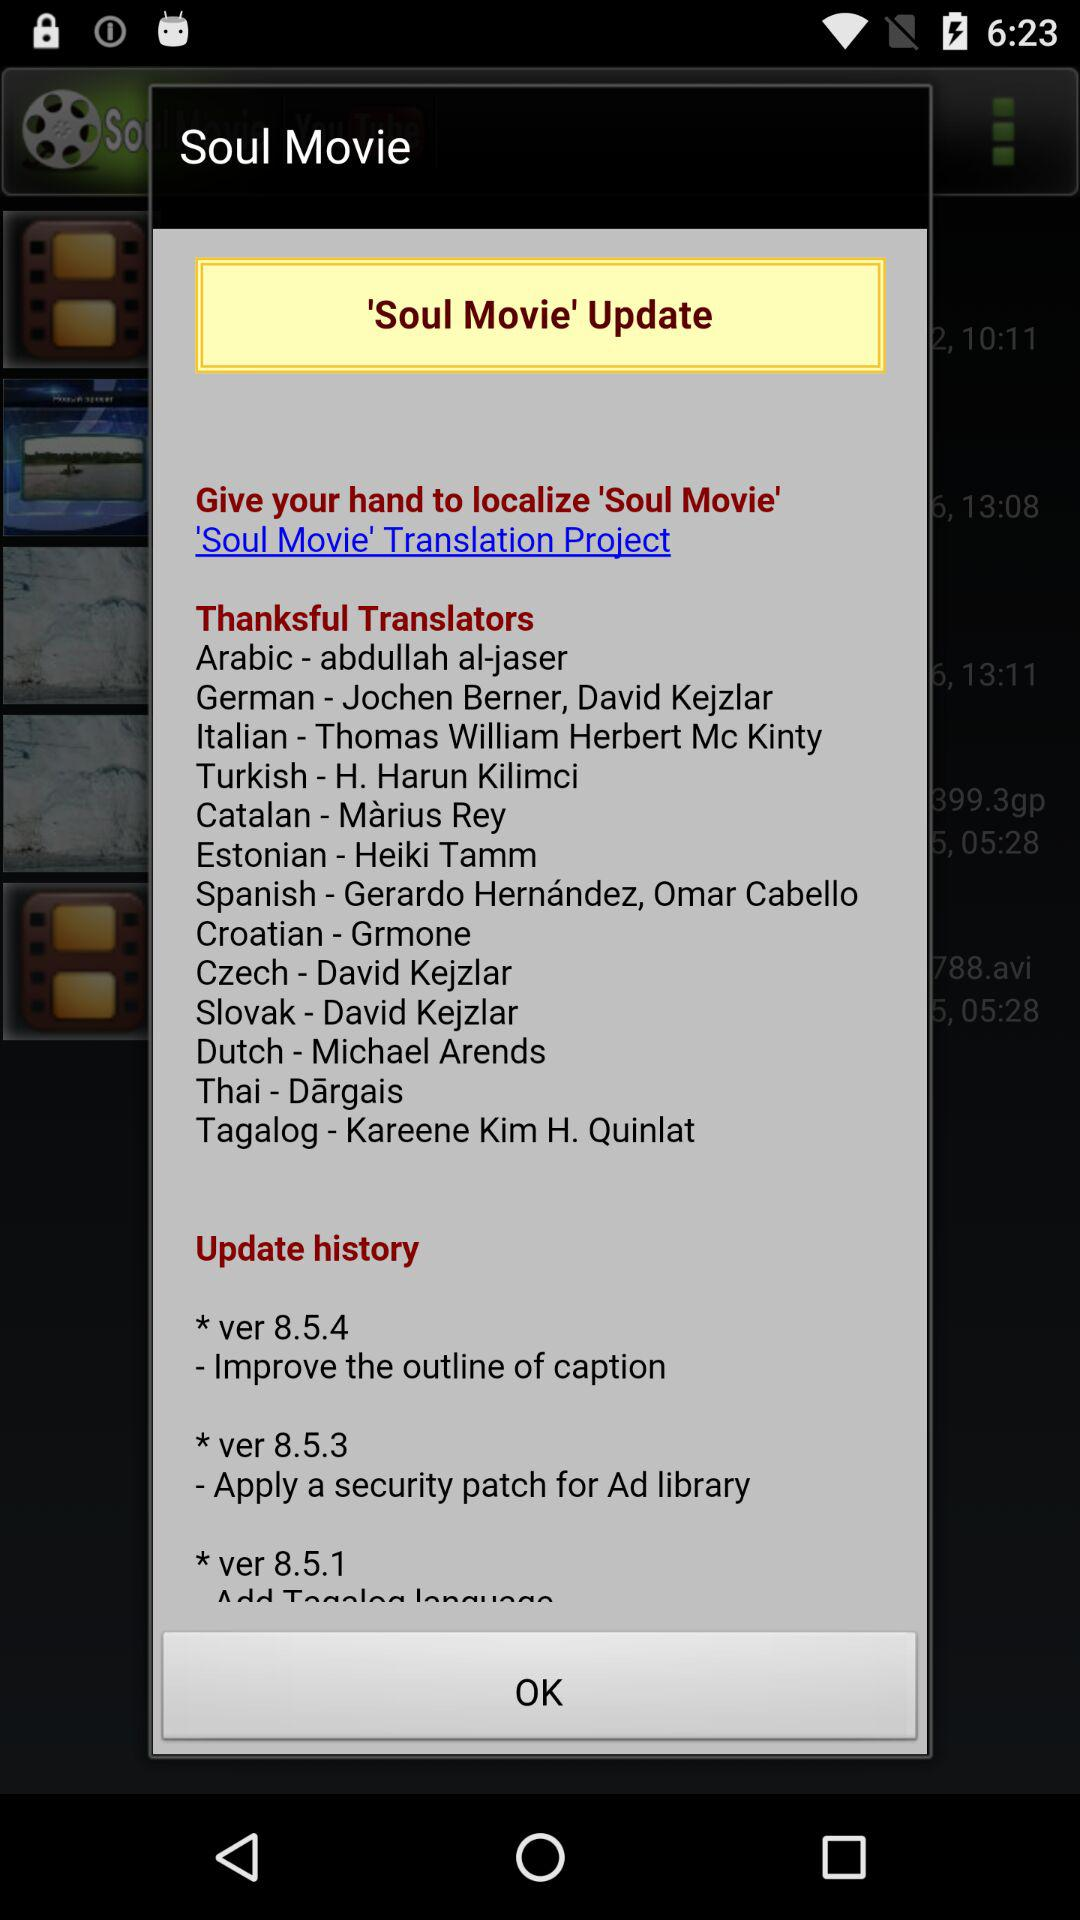Grmone is the translator of what language? Grmone is the translator of the "Croatian" language. 